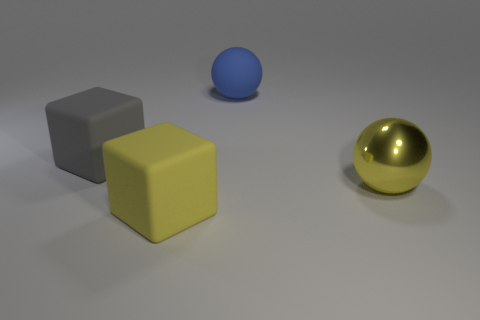There is a big matte object that is the same color as the metallic sphere; what is its shape?
Offer a very short reply. Cube. What material is the cube in front of the gray matte object?
Your answer should be compact. Rubber. How many things are either cyan metal cylinders or big matte cubes in front of the gray thing?
Ensure brevity in your answer.  1. The yellow metallic object that is the same size as the yellow rubber object is what shape?
Your answer should be compact. Sphere. What number of big cubes have the same color as the big metallic ball?
Your answer should be very brief. 1. Is the material of the big yellow object to the left of the blue ball the same as the large gray cube?
Give a very brief answer. Yes. What shape is the large gray thing?
Ensure brevity in your answer.  Cube. What number of yellow things are small rubber things or large metallic things?
Offer a terse response. 1. What number of other objects are the same material as the gray block?
Make the answer very short. 2. There is a thing that is on the right side of the large blue rubber thing; does it have the same shape as the big blue matte object?
Your response must be concise. Yes. 